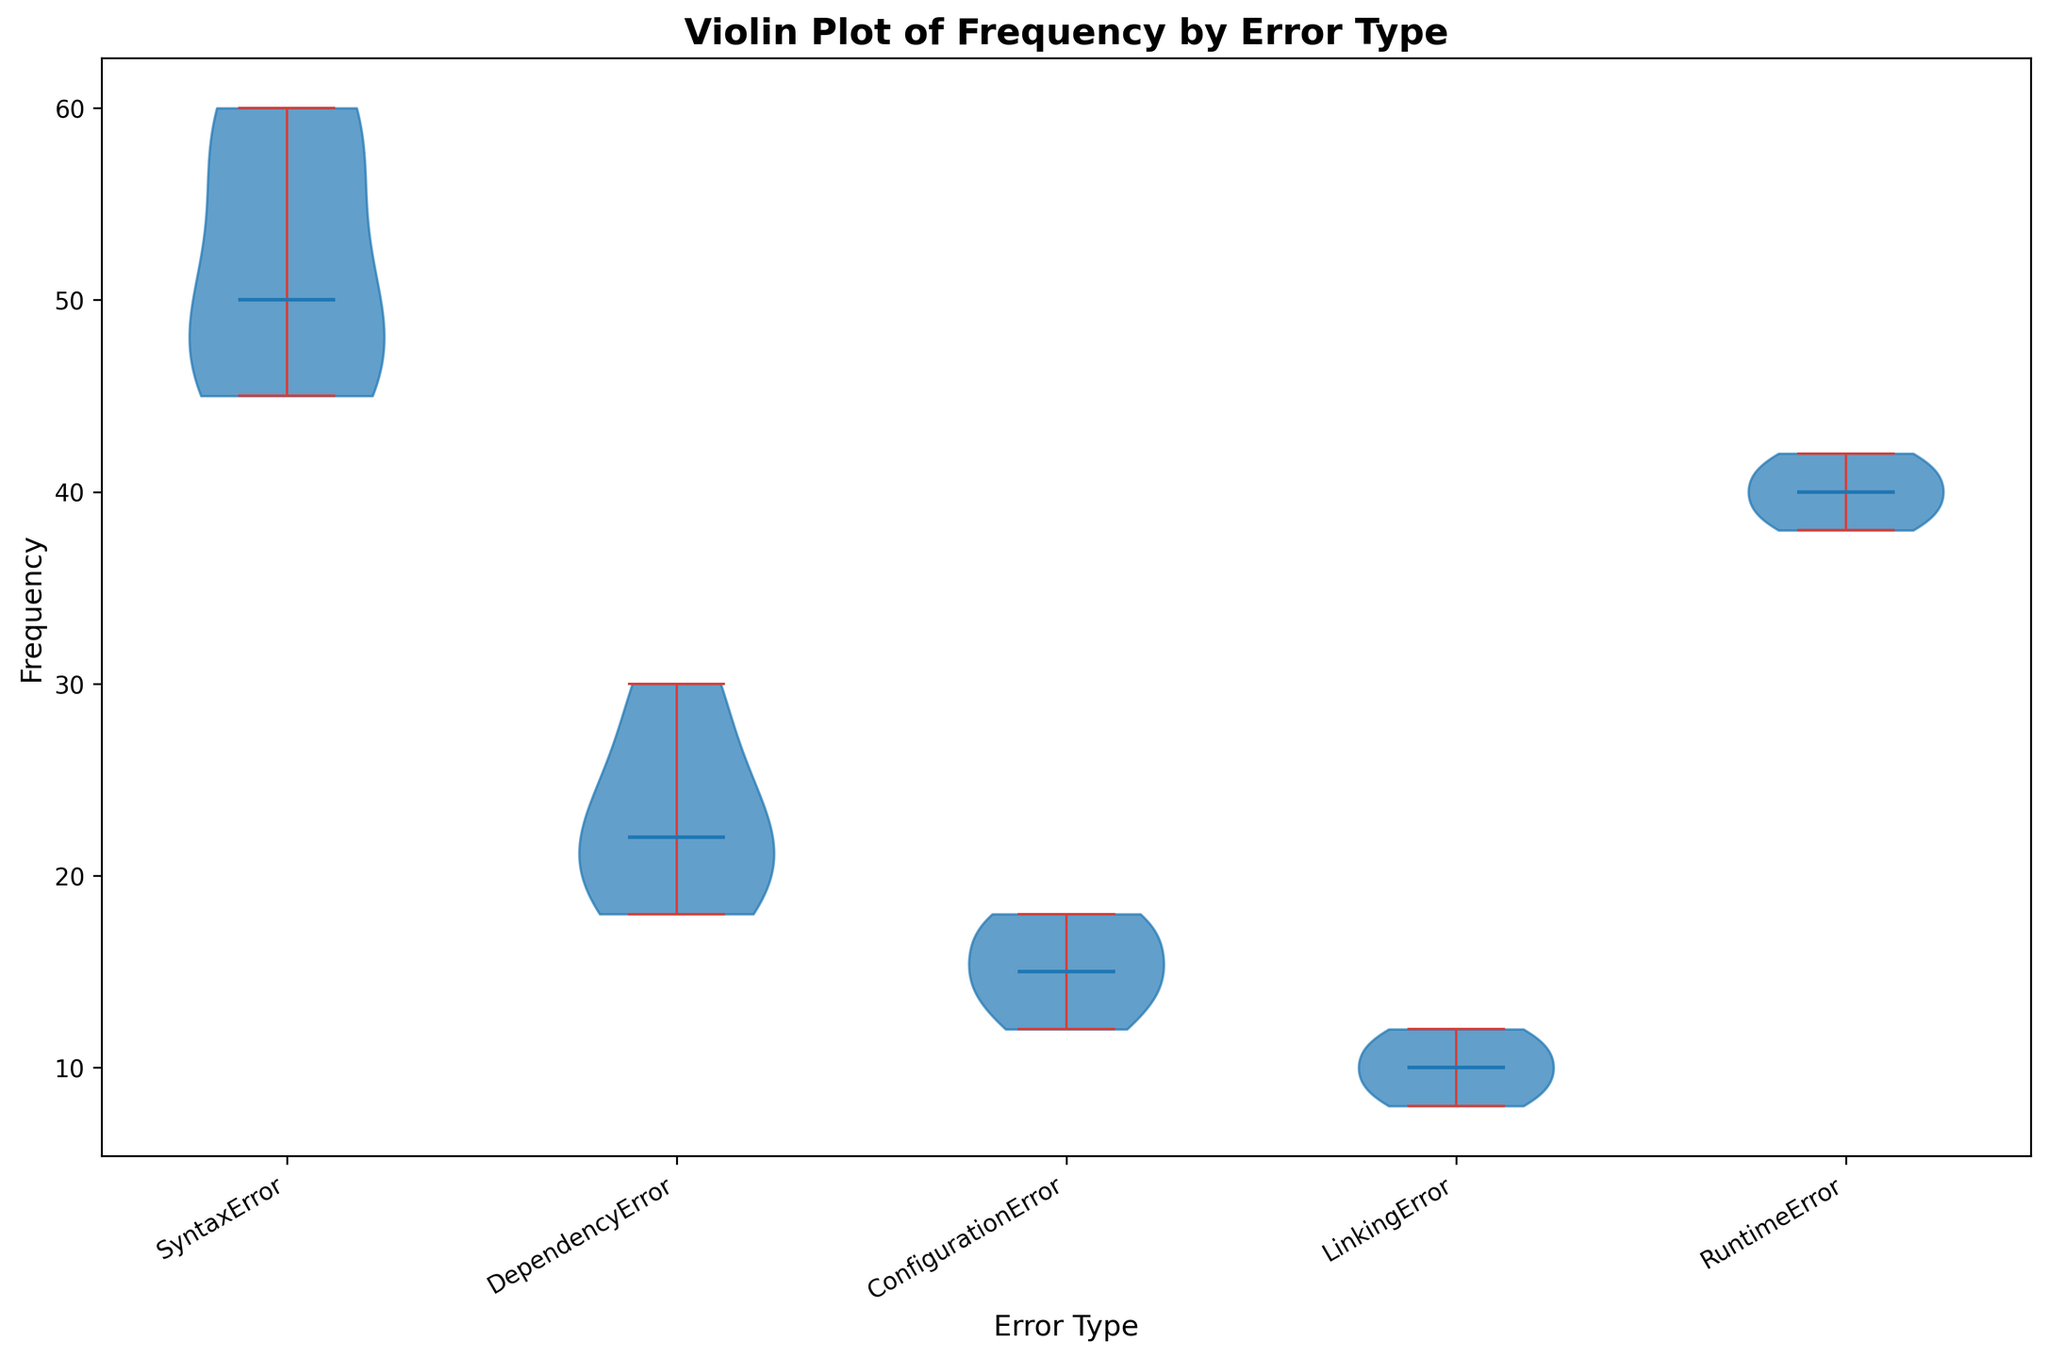What are the central tendency measures (median) of the frequency for each error type? To determine the median of the frequency for each error type, look for the white marker within the black bar inside each violin plot. These markers represent the median values of the data distributions. Identify the median for each of the error types (SyntaxError, DependencyError, ConfigurationError, LinkingError, RuntimeError).
Answer: The medians are: SyntaxError ~50, DependencyError ~22, ConfigurationError ~15, LinkingError ~10, RuntimeError ~40 Which error type has the widest spread in its frequency data? The spread is indicated by the width of each violin plot. The plot that appears the widest across the range of values shows the highest variability. In this case, visually check the range from the bottom to the top of each violin plot.
Answer: SyntaxError Among all error types, which one tends to have the lowest typical frequency? To find the error type with the lowest typical frequency, look at the overall shape and position of the violin plots. The plot located lowest relative to the y-axis indicates the lowest frequencies.
Answer: LinkingError Which error type has the most skewed frequency distribution? Skewness in the frequency distributions can be identified by looking at the symmetry of the violin plots. The plot with the most asymmetrical shape, either skewed right or left, shows the skewness of the data.
Answer: LinkingError Compare the median frequencies of SyntaxError and ConfigurationError. Which one is higher and by approximately how much? To compare, find the median values (white markers) of both SyntaxError and ConfigurationError in the violin plots. The difference between these median values will indicate how much higher one is compared to the other.
Answer: SyntaxError is higher by approximately 35 Which Error types have overlapping frequency ranges in their data distributions? Look for violin plots that visually overlap along the frequency axis. If the ranges of two plots intersect or are close, they have overlapping frequency ranges.
Answer: ConfigurationError and LinkingError Considering the distribution shapes, which error type appears to have the most consistent frequency? Consistency in this context means less variability, which is shown by a narrower and more concentrated violin plot shape. The type with the narrowest and most compact shape indicates the most consistent frequency.
Answer: RuntimeError How do the durations of DependencyError and SyntaxError compare in general? Though the plot is about frequency, we can make a general comparison based on the duration data provided: DependencyErrors have longer durations (4.2 to 6.0) compared to SyntaxErrors (1.9 to 3.0). This can be reasoned based on the background data used to generate the plot.
Answer: DependencyError durations are generally longer By visual inspection, what could be inferred about the typical range of frequencies for RuntimeError compared to DependencyError? Visually locate the range of frequencies for each error type. RuntimeError's range appears to be between 38 and 42, while DependencyError ranges from 18 to 30, which implies RuntimeError has a higher typical frequency range.
Answer: RuntimeError frequencies are higher and more concentrated Which error type is likely the least frequent overall based on the plot? Look at the collective data points along the y-axis, focusing on the lowest typical positions of the plots. This indicates the least frequent error type in terms of frequency distribution.
Answer: LinkingError 